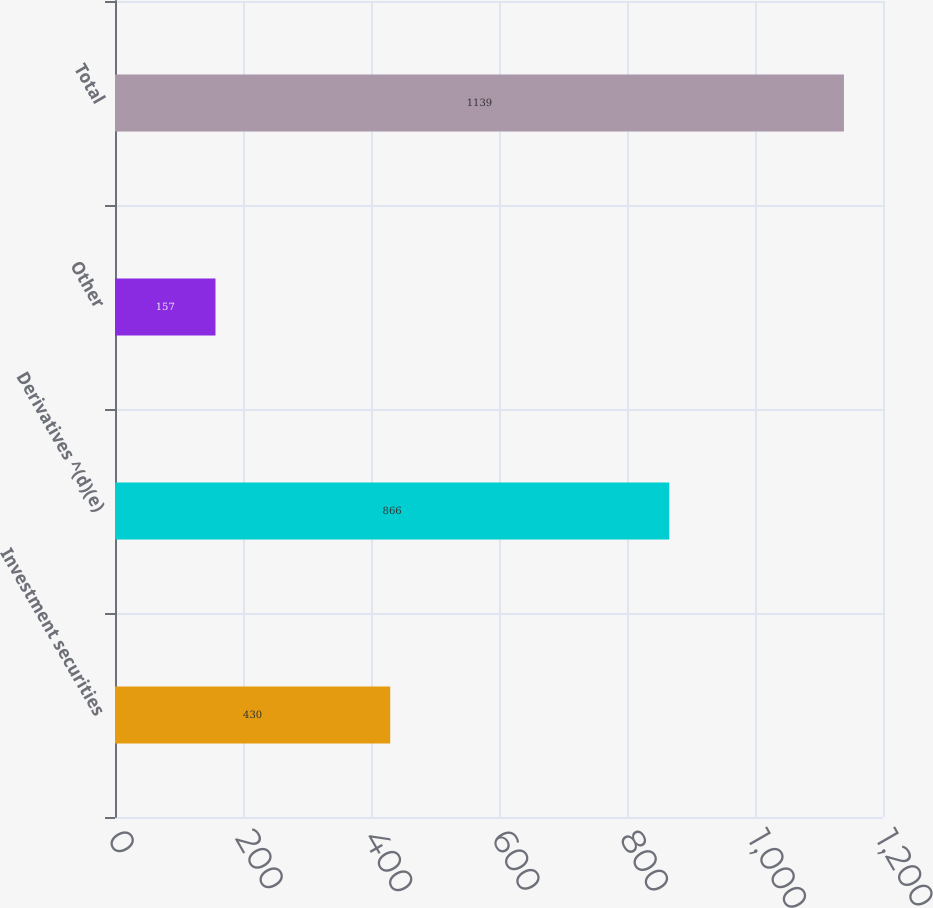<chart> <loc_0><loc_0><loc_500><loc_500><bar_chart><fcel>Investment securities<fcel>Derivatives ^(d)(e)<fcel>Other<fcel>Total<nl><fcel>430<fcel>866<fcel>157<fcel>1139<nl></chart> 